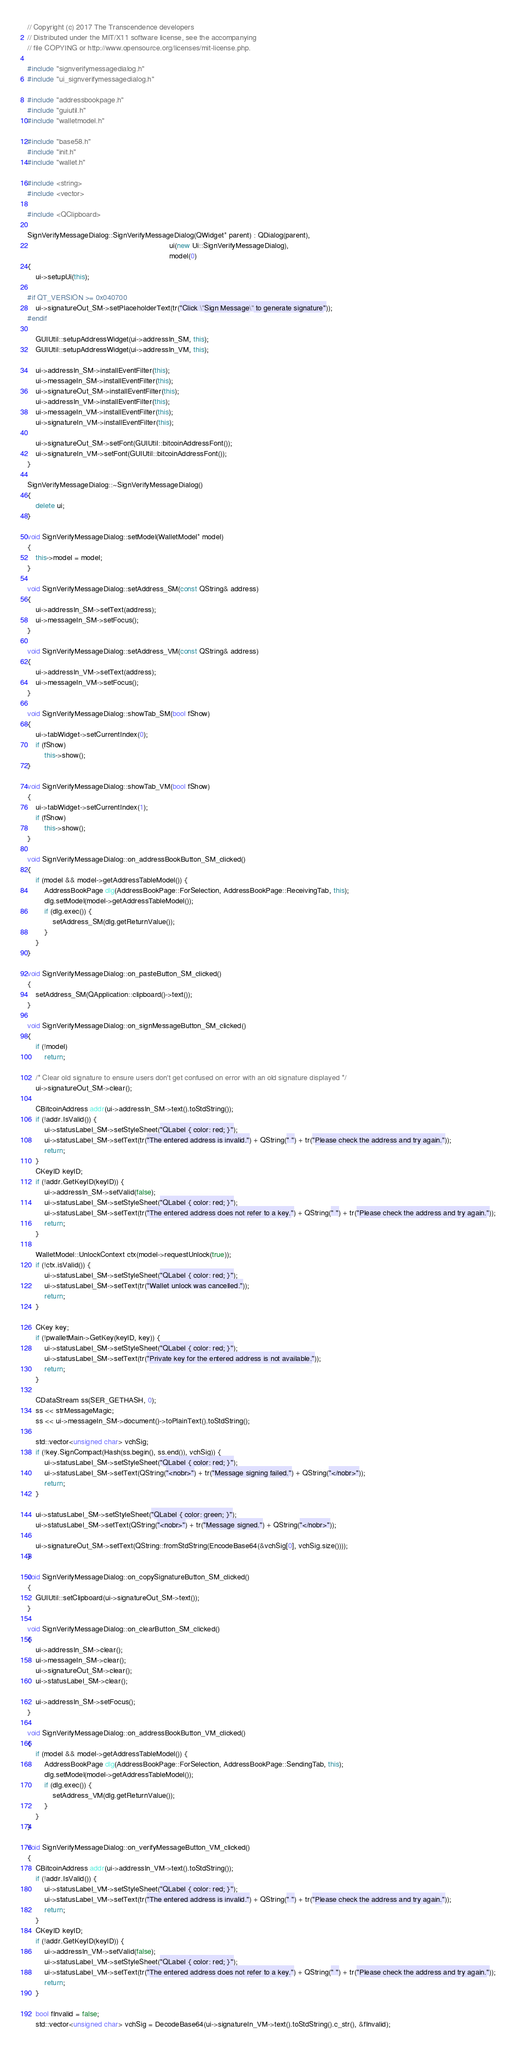<code> <loc_0><loc_0><loc_500><loc_500><_C++_>// Copyright (c) 2017 The Transcendence developers
// Distributed under the MIT/X11 software license, see the accompanying
// file COPYING or http://www.opensource.org/licenses/mit-license.php.

#include "signverifymessagedialog.h"
#include "ui_signverifymessagedialog.h"

#include "addressbookpage.h"
#include "guiutil.h"
#include "walletmodel.h"

#include "base58.h"
#include "init.h"
#include "wallet.h"

#include <string>
#include <vector>

#include <QClipboard>

SignVerifyMessageDialog::SignVerifyMessageDialog(QWidget* parent) : QDialog(parent),
                                                                    ui(new Ui::SignVerifyMessageDialog),
                                                                    model(0)
{
    ui->setupUi(this);

#if QT_VERSION >= 0x040700
    ui->signatureOut_SM->setPlaceholderText(tr("Click \"Sign Message\" to generate signature"));
#endif

    GUIUtil::setupAddressWidget(ui->addressIn_SM, this);
    GUIUtil::setupAddressWidget(ui->addressIn_VM, this);

    ui->addressIn_SM->installEventFilter(this);
    ui->messageIn_SM->installEventFilter(this);
    ui->signatureOut_SM->installEventFilter(this);
    ui->addressIn_VM->installEventFilter(this);
    ui->messageIn_VM->installEventFilter(this);
    ui->signatureIn_VM->installEventFilter(this);

    ui->signatureOut_SM->setFont(GUIUtil::bitcoinAddressFont());
    ui->signatureIn_VM->setFont(GUIUtil::bitcoinAddressFont());
}

SignVerifyMessageDialog::~SignVerifyMessageDialog()
{
    delete ui;
}

void SignVerifyMessageDialog::setModel(WalletModel* model)
{
    this->model = model;
}

void SignVerifyMessageDialog::setAddress_SM(const QString& address)
{
    ui->addressIn_SM->setText(address);
    ui->messageIn_SM->setFocus();
}

void SignVerifyMessageDialog::setAddress_VM(const QString& address)
{
    ui->addressIn_VM->setText(address);
    ui->messageIn_VM->setFocus();
}

void SignVerifyMessageDialog::showTab_SM(bool fShow)
{
    ui->tabWidget->setCurrentIndex(0);
    if (fShow)
        this->show();
}

void SignVerifyMessageDialog::showTab_VM(bool fShow)
{
    ui->tabWidget->setCurrentIndex(1);
    if (fShow)
        this->show();
}

void SignVerifyMessageDialog::on_addressBookButton_SM_clicked()
{
    if (model && model->getAddressTableModel()) {
        AddressBookPage dlg(AddressBookPage::ForSelection, AddressBookPage::ReceivingTab, this);
        dlg.setModel(model->getAddressTableModel());
        if (dlg.exec()) {
            setAddress_SM(dlg.getReturnValue());
        }
    }
}

void SignVerifyMessageDialog::on_pasteButton_SM_clicked()
{
    setAddress_SM(QApplication::clipboard()->text());
}

void SignVerifyMessageDialog::on_signMessageButton_SM_clicked()
{
    if (!model)
        return;

    /* Clear old signature to ensure users don't get confused on error with an old signature displayed */
    ui->signatureOut_SM->clear();

    CBitcoinAddress addr(ui->addressIn_SM->text().toStdString());
    if (!addr.IsValid()) {
        ui->statusLabel_SM->setStyleSheet("QLabel { color: red; }");
        ui->statusLabel_SM->setText(tr("The entered address is invalid.") + QString(" ") + tr("Please check the address and try again."));
        return;
    }
    CKeyID keyID;
    if (!addr.GetKeyID(keyID)) {
        ui->addressIn_SM->setValid(false);
        ui->statusLabel_SM->setStyleSheet("QLabel { color: red; }");
        ui->statusLabel_SM->setText(tr("The entered address does not refer to a key.") + QString(" ") + tr("Please check the address and try again."));
        return;
    }

    WalletModel::UnlockContext ctx(model->requestUnlock(true));
    if (!ctx.isValid()) {
        ui->statusLabel_SM->setStyleSheet("QLabel { color: red; }");
        ui->statusLabel_SM->setText(tr("Wallet unlock was cancelled."));
        return;
    }

    CKey key;
    if (!pwalletMain->GetKey(keyID, key)) {
        ui->statusLabel_SM->setStyleSheet("QLabel { color: red; }");
        ui->statusLabel_SM->setText(tr("Private key for the entered address is not available."));
        return;
    }

    CDataStream ss(SER_GETHASH, 0);
    ss << strMessageMagic;
    ss << ui->messageIn_SM->document()->toPlainText().toStdString();

    std::vector<unsigned char> vchSig;
    if (!key.SignCompact(Hash(ss.begin(), ss.end()), vchSig)) {
        ui->statusLabel_SM->setStyleSheet("QLabel { color: red; }");
        ui->statusLabel_SM->setText(QString("<nobr>") + tr("Message signing failed.") + QString("</nobr>"));
        return;
    }

    ui->statusLabel_SM->setStyleSheet("QLabel { color: green; }");
    ui->statusLabel_SM->setText(QString("<nobr>") + tr("Message signed.") + QString("</nobr>"));

    ui->signatureOut_SM->setText(QString::fromStdString(EncodeBase64(&vchSig[0], vchSig.size())));
}

void SignVerifyMessageDialog::on_copySignatureButton_SM_clicked()
{
    GUIUtil::setClipboard(ui->signatureOut_SM->text());
}

void SignVerifyMessageDialog::on_clearButton_SM_clicked()
{
    ui->addressIn_SM->clear();
    ui->messageIn_SM->clear();
    ui->signatureOut_SM->clear();
    ui->statusLabel_SM->clear();

    ui->addressIn_SM->setFocus();
}

void SignVerifyMessageDialog::on_addressBookButton_VM_clicked()
{
    if (model && model->getAddressTableModel()) {
        AddressBookPage dlg(AddressBookPage::ForSelection, AddressBookPage::SendingTab, this);
        dlg.setModel(model->getAddressTableModel());
        if (dlg.exec()) {
            setAddress_VM(dlg.getReturnValue());
        }
    }
}

void SignVerifyMessageDialog::on_verifyMessageButton_VM_clicked()
{
    CBitcoinAddress addr(ui->addressIn_VM->text().toStdString());
    if (!addr.IsValid()) {
        ui->statusLabel_VM->setStyleSheet("QLabel { color: red; }");
        ui->statusLabel_VM->setText(tr("The entered address is invalid.") + QString(" ") + tr("Please check the address and try again."));
        return;
    }
    CKeyID keyID;
    if (!addr.GetKeyID(keyID)) {
        ui->addressIn_VM->setValid(false);
        ui->statusLabel_VM->setStyleSheet("QLabel { color: red; }");
        ui->statusLabel_VM->setText(tr("The entered address does not refer to a key.") + QString(" ") + tr("Please check the address and try again."));
        return;
    }

    bool fInvalid = false;
    std::vector<unsigned char> vchSig = DecodeBase64(ui->signatureIn_VM->text().toStdString().c_str(), &fInvalid);
</code> 